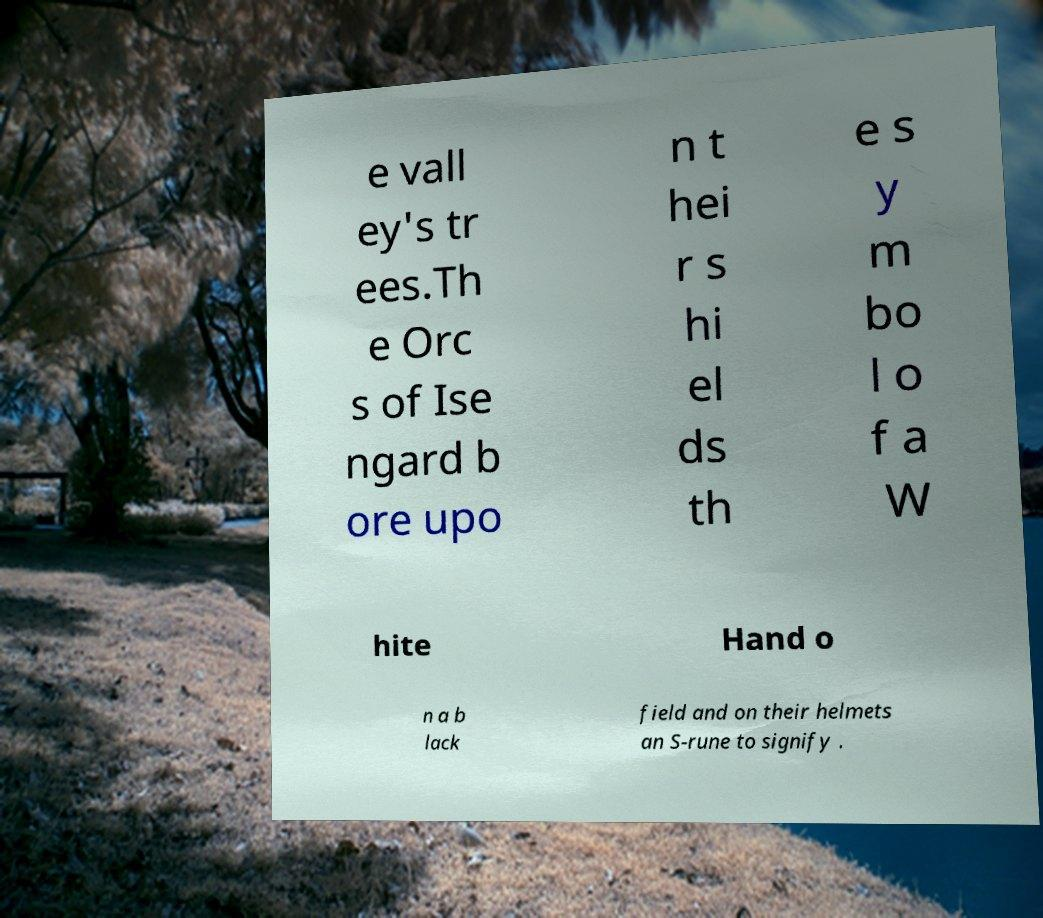Can you read and provide the text displayed in the image?This photo seems to have some interesting text. Can you extract and type it out for me? e vall ey's tr ees.Th e Orc s of Ise ngard b ore upo n t hei r s hi el ds th e s y m bo l o f a W hite Hand o n a b lack field and on their helmets an S-rune to signify . 